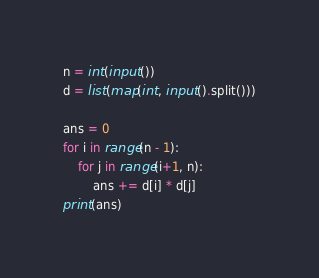Convert code to text. <code><loc_0><loc_0><loc_500><loc_500><_Python_>n = int(input())
d = list(map(int, input().split()))

ans = 0
for i in range(n - 1):
    for j in range(i+1, n):
        ans += d[i] * d[j]
print(ans)
</code> 